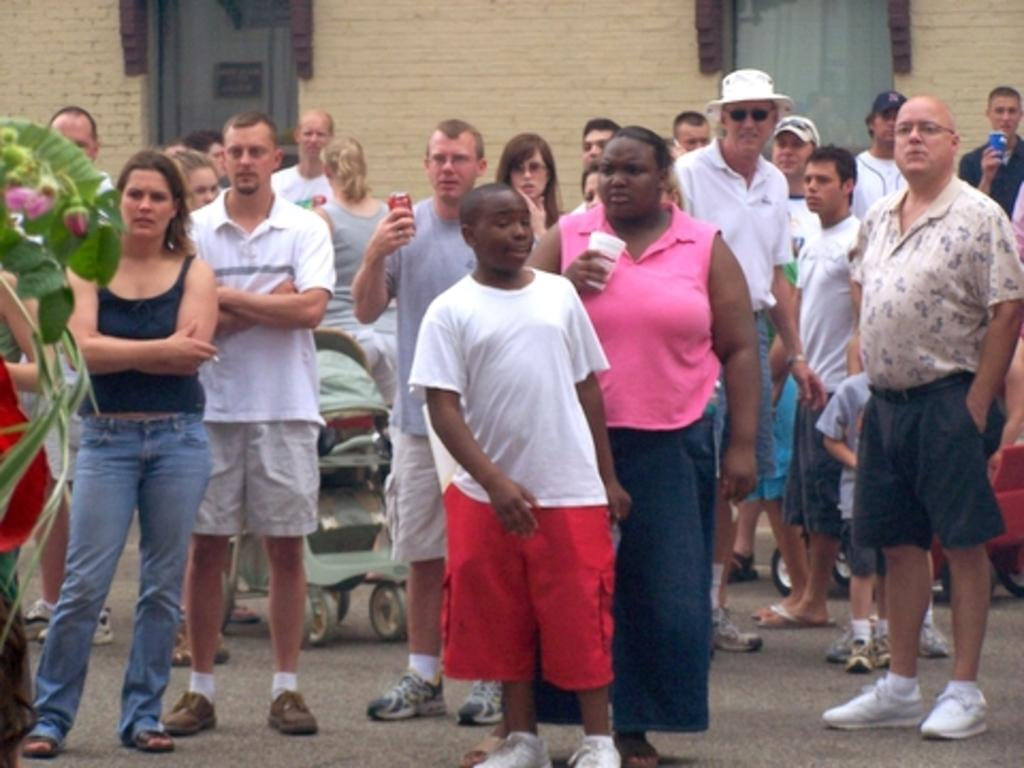What can be seen in the image involving multiple individuals? There are groups of people standing in the image. What type of transportation for a young child is present in the image? There is a stroller in the image. What type of vegetation can be seen on the left side of the image? There are leaves and flower buds on the left side of the image. What type of structure is visible in the image? There is a house with doors in the image. What type of sack is being carried by the army in the image? There is no army or sack present in the image. What is the sister doing in the image? There is no mention of a sister in the image. 